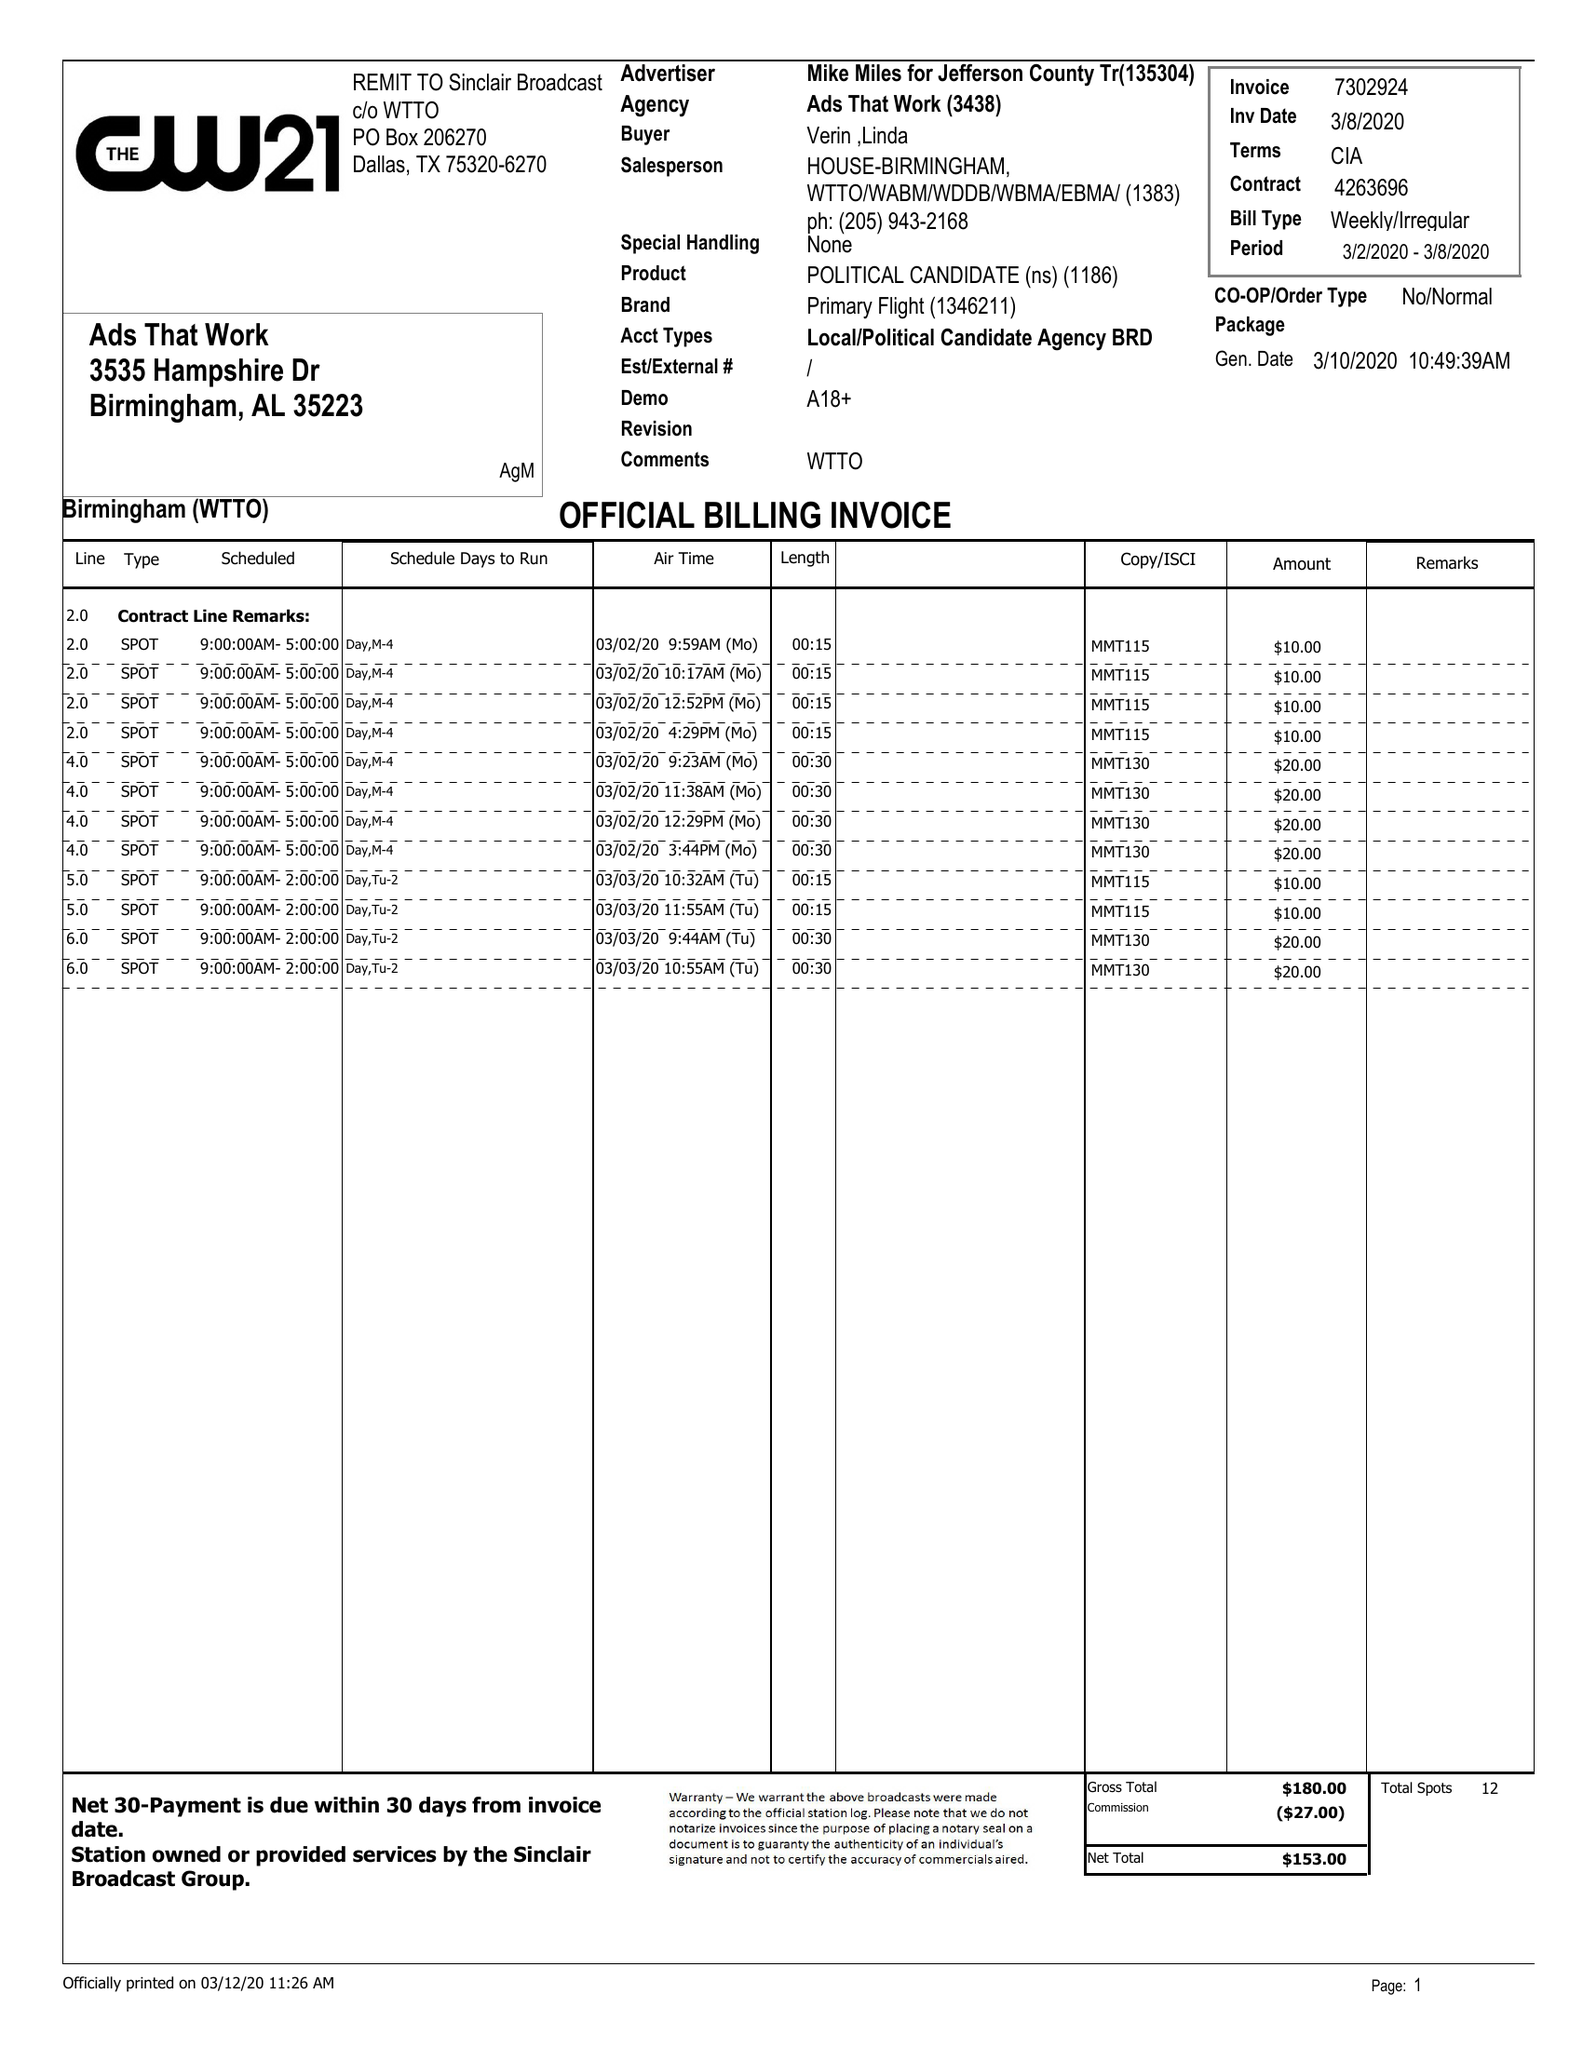What is the value for the advertiser?
Answer the question using a single word or phrase. MIKE MILES FOR JEFFERSON COUNTY TREASURER 